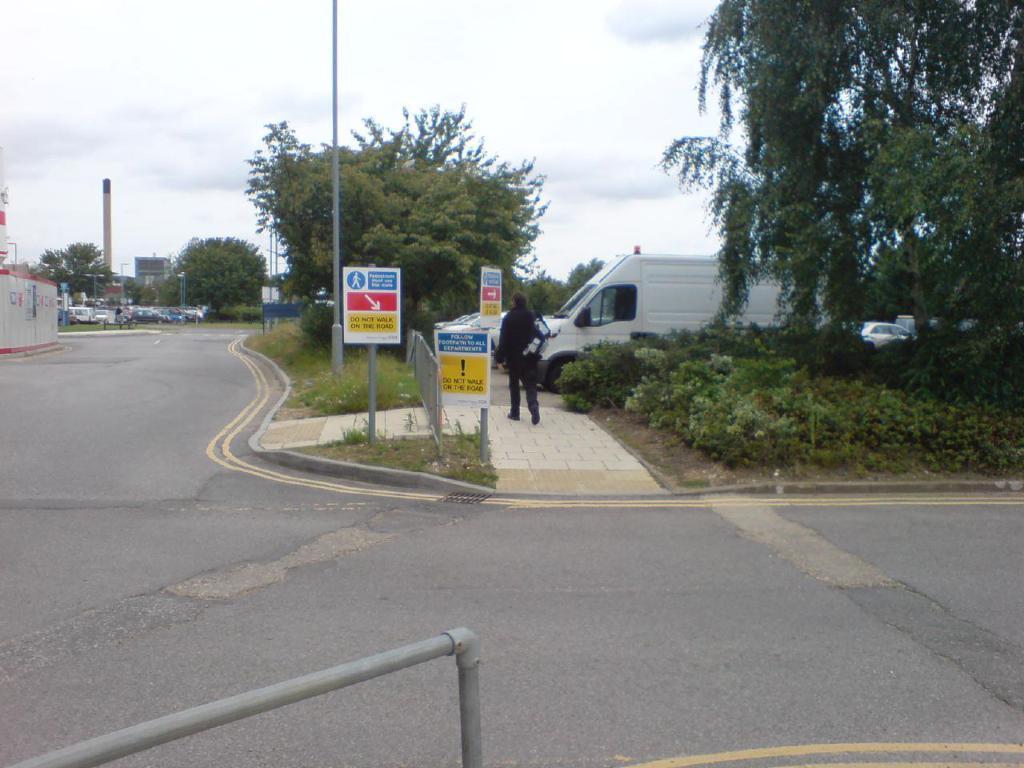What does the yellow section of the taller sign say?
Provide a succinct answer. Do not walk on the road. 